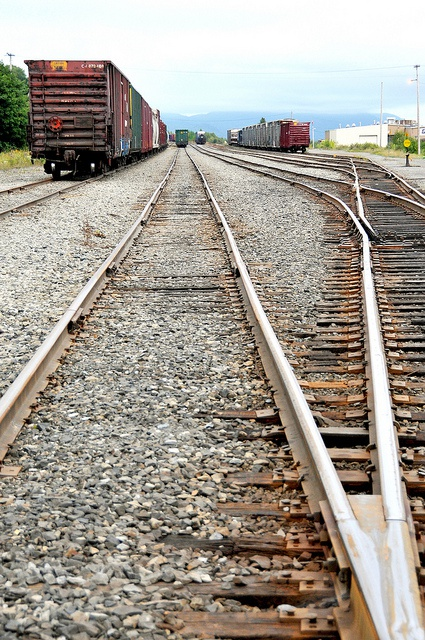Describe the objects in this image and their specific colors. I can see train in white, black, gray, brown, and maroon tones, train in white, gray, maroon, black, and darkgray tones, train in white, gray, teal, and darkgray tones, and train in white, gray, and black tones in this image. 